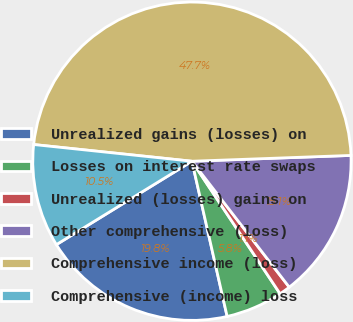<chart> <loc_0><loc_0><loc_500><loc_500><pie_chart><fcel>Unrealized gains (losses) on<fcel>Losses on interest rate swaps<fcel>Unrealized (losses) gains on<fcel>Other comprehensive (loss)<fcel>Comprehensive income (loss)<fcel>Comprehensive (income) loss<nl><fcel>19.77%<fcel>5.79%<fcel>1.13%<fcel>15.11%<fcel>47.74%<fcel>10.45%<nl></chart> 